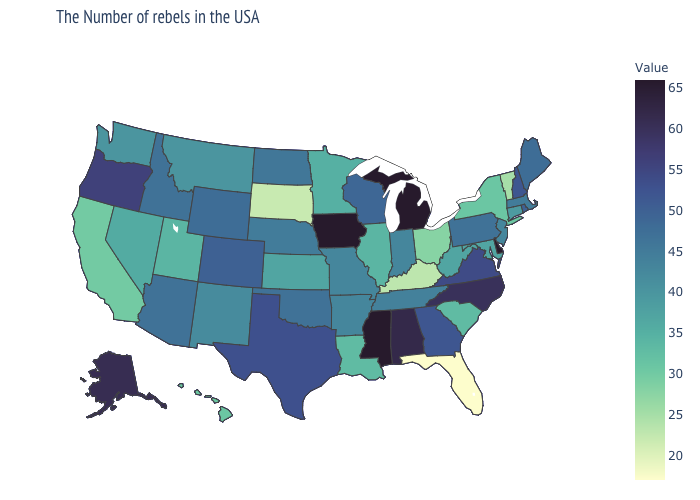Which states have the lowest value in the USA?
Write a very short answer. Florida. Which states have the lowest value in the West?
Be succinct. California. Among the states that border Missouri , does Illinois have the highest value?
Concise answer only. No. Is the legend a continuous bar?
Write a very short answer. Yes. Does the map have missing data?
Give a very brief answer. No. Which states hav the highest value in the MidWest?
Be succinct. Michigan, Iowa. 